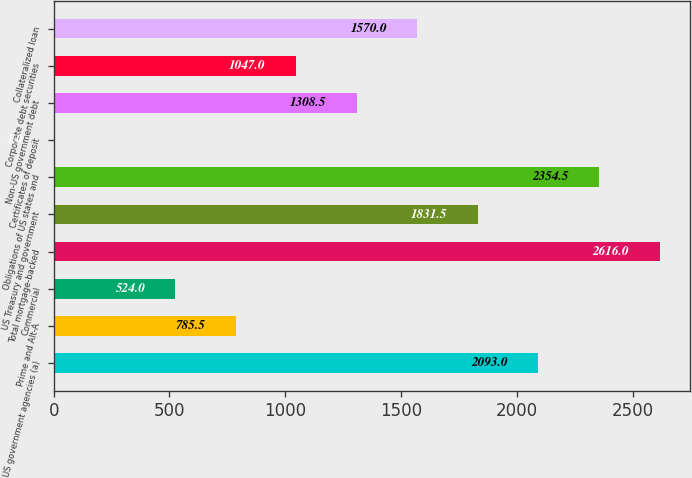Convert chart. <chart><loc_0><loc_0><loc_500><loc_500><bar_chart><fcel>US government agencies (a)<fcel>Prime and Alt-A<fcel>Commercial<fcel>Total mortgage-backed<fcel>US Treasury and government<fcel>Obligations of US states and<fcel>Certificates of deposit<fcel>Non-US government debt<fcel>Corporate debt securities<fcel>Collateralized loan<nl><fcel>2093<fcel>785.5<fcel>524<fcel>2616<fcel>1831.5<fcel>2354.5<fcel>1<fcel>1308.5<fcel>1047<fcel>1570<nl></chart> 